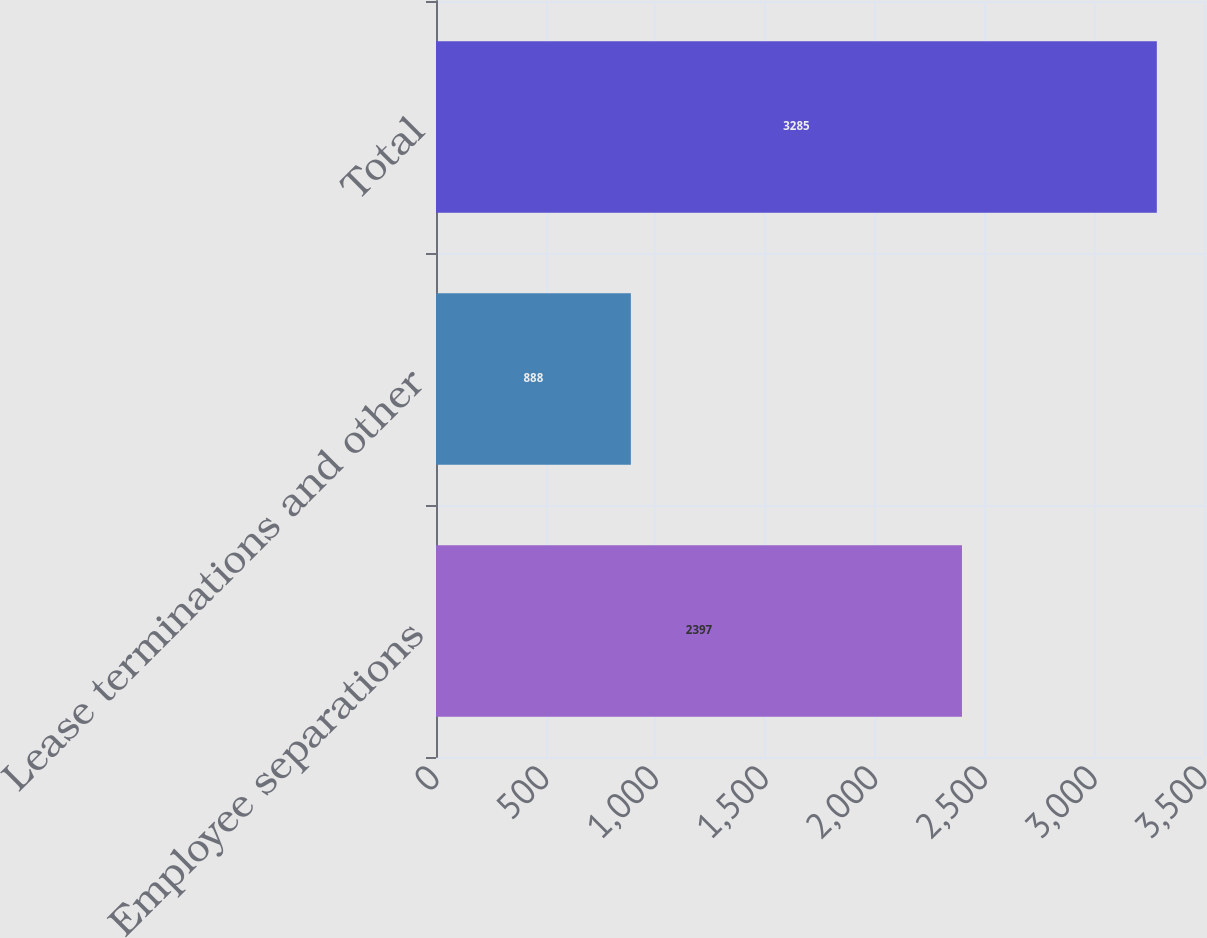Convert chart to OTSL. <chart><loc_0><loc_0><loc_500><loc_500><bar_chart><fcel>Employee separations<fcel>Lease terminations and other<fcel>Total<nl><fcel>2397<fcel>888<fcel>3285<nl></chart> 